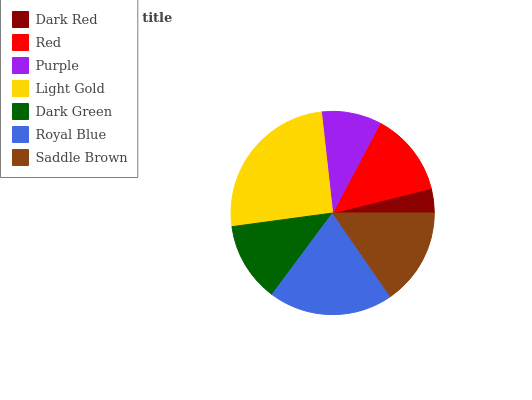Is Dark Red the minimum?
Answer yes or no. Yes. Is Light Gold the maximum?
Answer yes or no. Yes. Is Red the minimum?
Answer yes or no. No. Is Red the maximum?
Answer yes or no. No. Is Red greater than Dark Red?
Answer yes or no. Yes. Is Dark Red less than Red?
Answer yes or no. Yes. Is Dark Red greater than Red?
Answer yes or no. No. Is Red less than Dark Red?
Answer yes or no. No. Is Red the high median?
Answer yes or no. Yes. Is Red the low median?
Answer yes or no. Yes. Is Dark Green the high median?
Answer yes or no. No. Is Dark Red the low median?
Answer yes or no. No. 